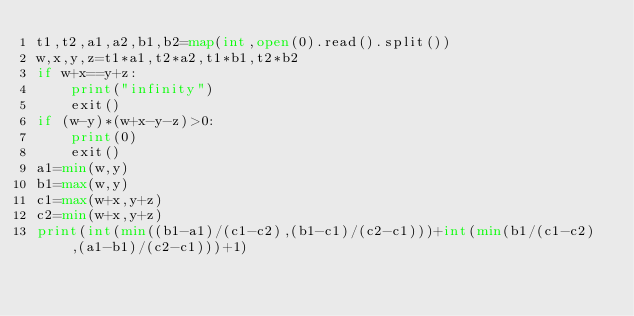Convert code to text. <code><loc_0><loc_0><loc_500><loc_500><_Python_>t1,t2,a1,a2,b1,b2=map(int,open(0).read().split())
w,x,y,z=t1*a1,t2*a2,t1*b1,t2*b2
if w+x==y+z:
	print("infinity")
	exit()
if (w-y)*(w+x-y-z)>0:
	print(0)
	exit()
a1=min(w,y)
b1=max(w,y)
c1=max(w+x,y+z)
c2=min(w+x,y+z)
print(int(min((b1-a1)/(c1-c2),(b1-c1)/(c2-c1)))+int(min(b1/(c1-c2),(a1-b1)/(c2-c1)))+1)</code> 